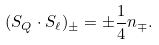<formula> <loc_0><loc_0><loc_500><loc_500>( { S } _ { Q } \cdot { S } _ { \ell } ) _ { \pm } = \pm \frac { 1 } { 4 } n _ { \mp } .</formula> 